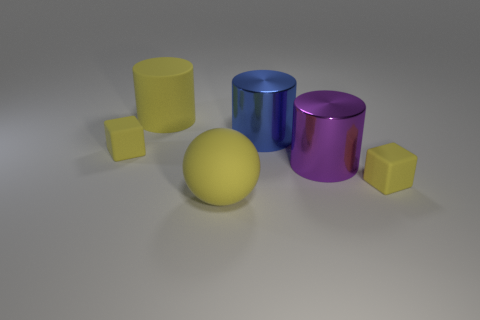What shape is the yellow rubber thing that is on the right side of the yellow matte cylinder and behind the rubber ball? The yellow rubber object positioned to the right of the matte yellow cylinder and behind the yellow rubber ball is a cube, distinguished by its six equal square faces and 90-degree angles. 